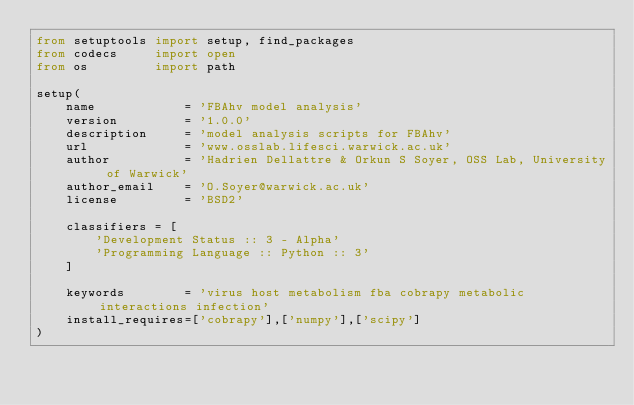<code> <loc_0><loc_0><loc_500><loc_500><_Python_>from setuptools import setup, find_packages
from codecs     import open
from os         import path

setup(
    name            = 'FBAhv model analysis'
    version         = '1.0.0'
    description     = 'model analysis scripts for FBAhv'
    url             = 'www.osslab.lifesci.warwick.ac.uk'
    author          = 'Hadrien Dellattre & Orkun S Soyer, OSS Lab, University of Warwick'
    author_email    = 'O.Soyer@warwick.ac.uk'
    license         = 'BSD2'

    classifiers = [
        'Development Status :: 3 - Alpha'
        'Programming Language :: Python :: 3'
    ]

    keywords        = 'virus host metabolism fba cobrapy metabolic interactions infection'
    install_requires=['cobrapy'],['numpy'],['scipy']
)
</code> 